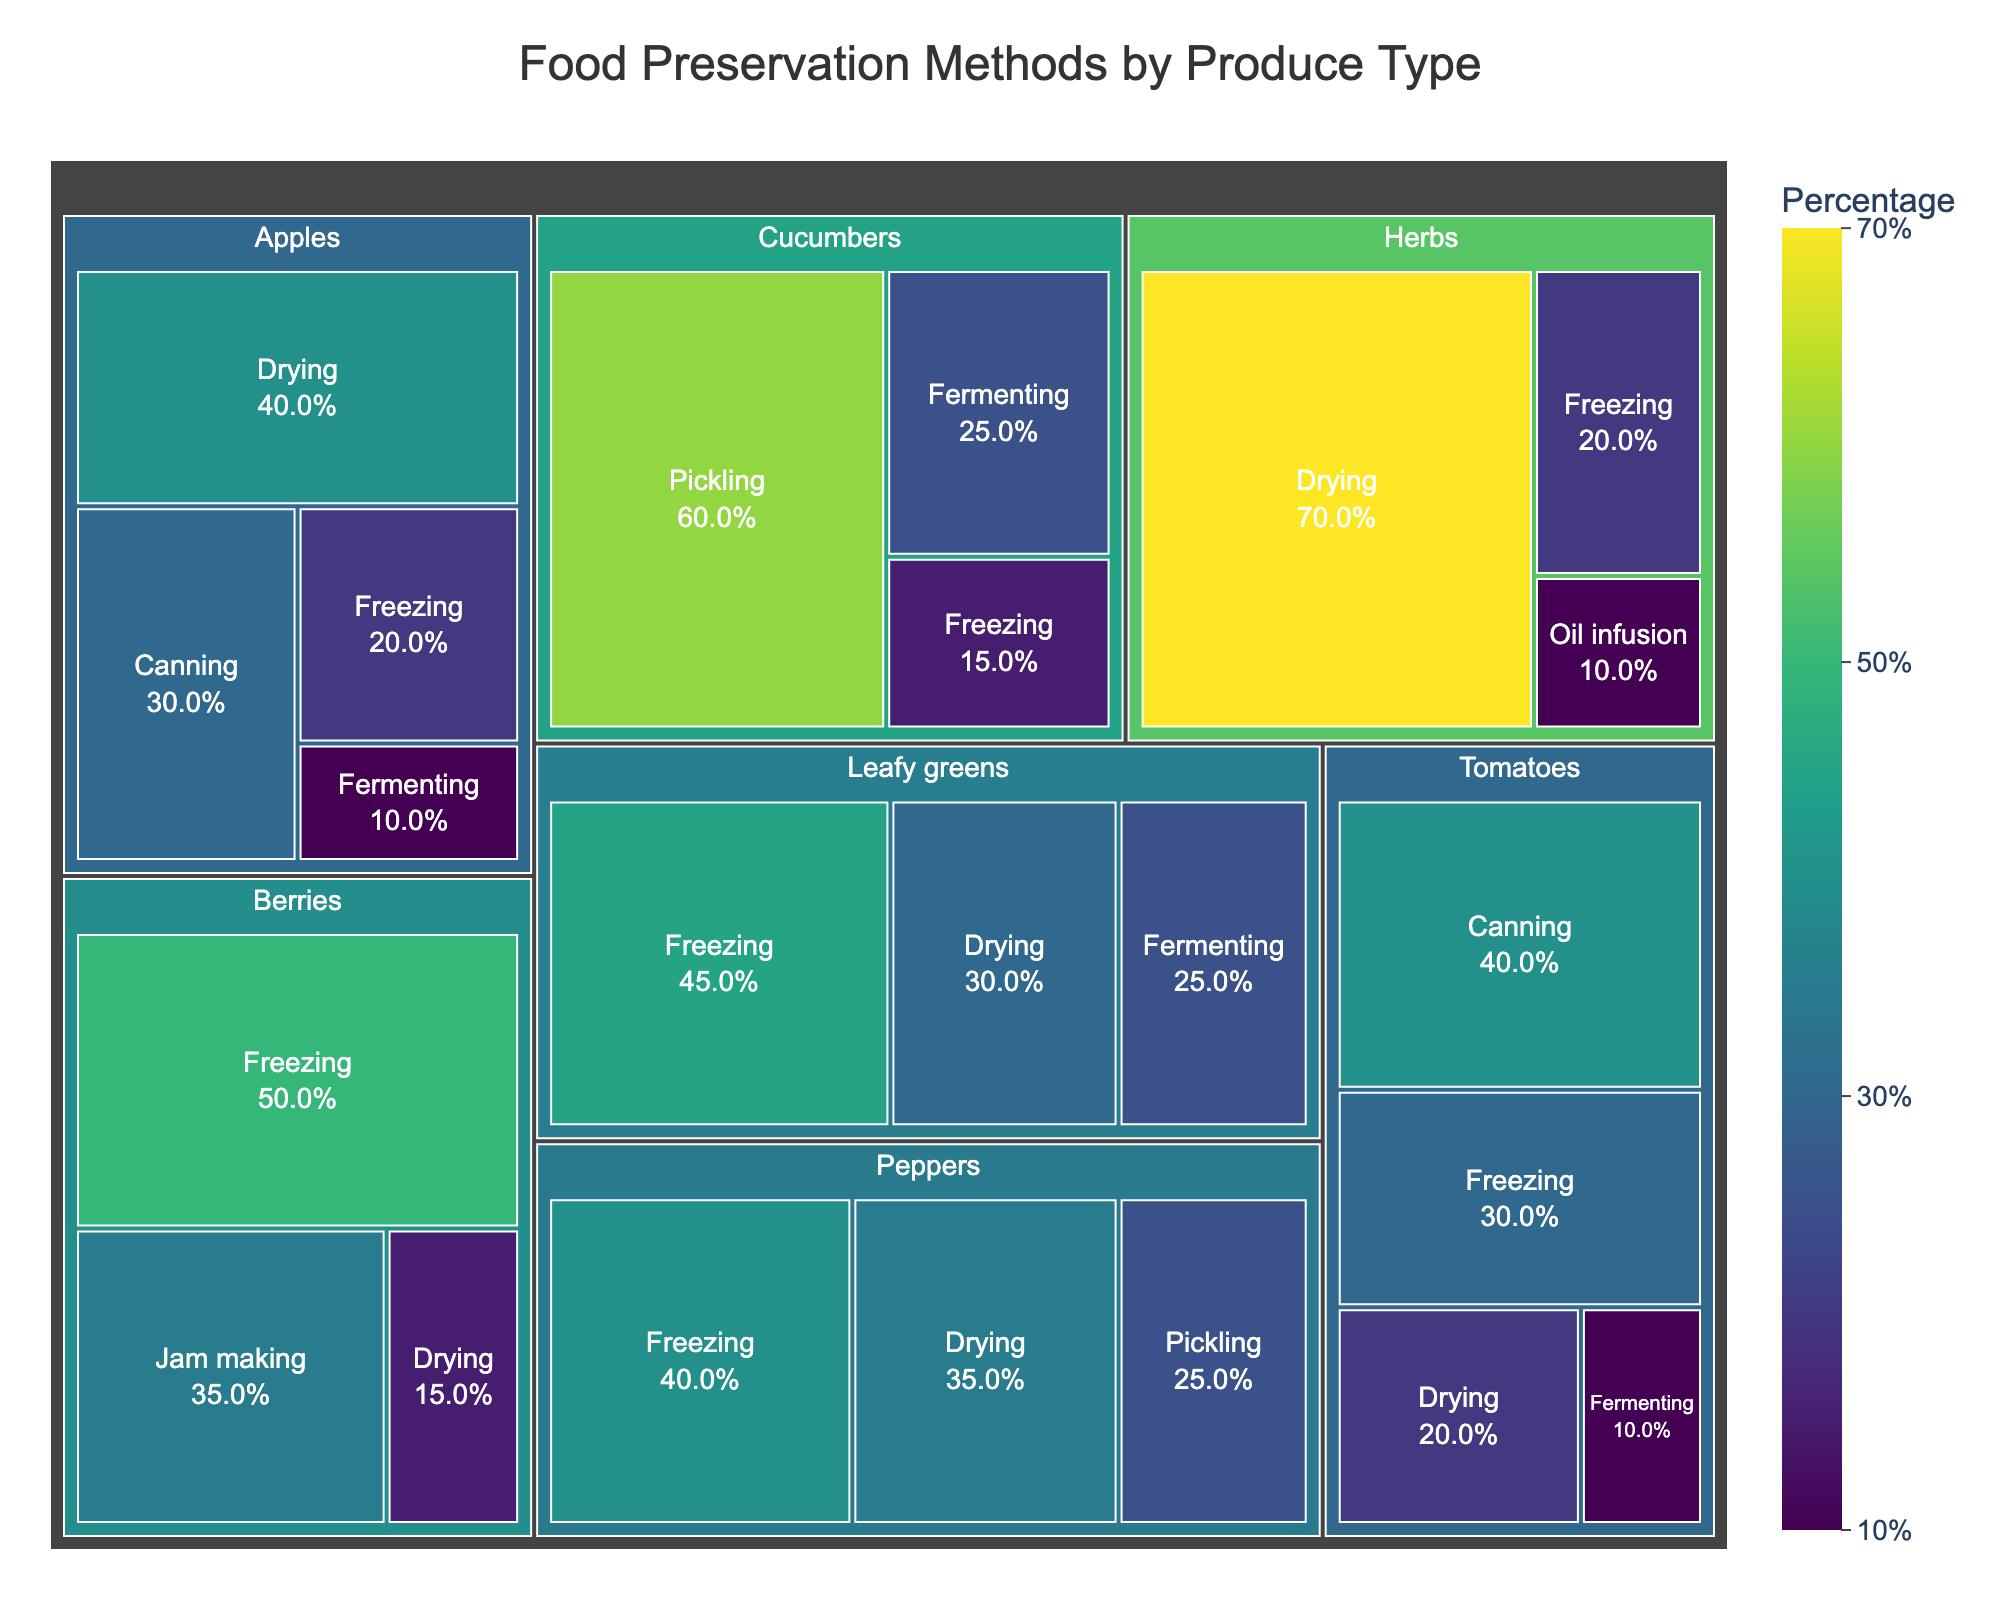What's the most commonly used preservation method for cucumbers? By looking at the treemap, the largest segment for cucumbers represents pickling, with a percentage of 60%. Hence, pickling is the most commonly used preservation method for cucumbers.
Answer: Pickling Which produce type has drying as the most popular preservation method? Check each produce category for where the drying segment is the largest. Herbs have drying as the most popular method with 70%.
Answer: Herbs What is the combined percentage of freezing and drying methods used for peppers? First, find the freezing percentage for peppers, which is 40%, and the drying percentage is 35%. Add these percentages: 40% + 35% = 75%.
Answer: 75% How does the popularity of freezing compare between tomatoes and leafy greens? For tomatoes, freezing is 30%. For leafy greens, freezing is 45%. Freezing is less popular for tomatoes compared to leafy greens.
Answer: Less popular for tomatoes Does any produce have fermenting as the least common preservation method, and if so, which one? Look at the smallest percentages for each produce type. For tomatoes and apples, fermenting has the lowest percentage, with 10% each.
Answer: Tomatoes, Apples Which produce type has the most diverse preservation methods based on the number of different methods used? Check the number of unique segments for each produce type. Tomatoes, cucumbers, and leafy greens each show four distinct preservation methods.
Answer: Tomatoes, Cucumbers, Leafy greens What percentage of berries is preserved through methods other than freezing and jam making? Subtract the percentages of freezing (50%) and jam making (35%) from 100%. Remaining percentage = 100% - (50% + 35%) = 15%.
Answer: 15% For apples, what is the difference in percentage between drying and canning preservation methods? Find the drying percentage (40%) and canning percentage (30%) and calculate the difference: 40% - 30% = 10%.
Answer: 10% Among all produce types, which preservation method has the highest percentage and what is it? Identify the highest percentage across all segments. Herbs dried at 70% has the highest percentage.
Answer: Drying of Herbs at 70% 